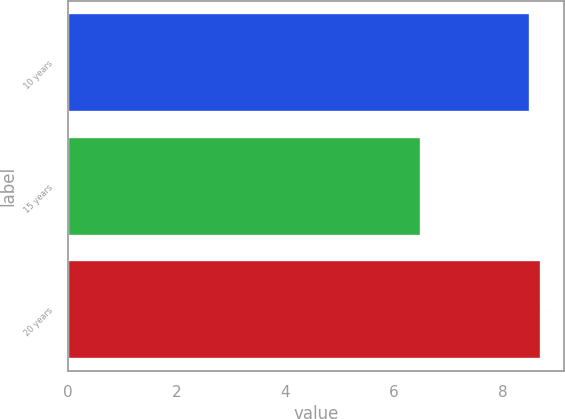<chart> <loc_0><loc_0><loc_500><loc_500><bar_chart><fcel>10 years<fcel>15 years<fcel>20 years<nl><fcel>8.5<fcel>6.5<fcel>8.7<nl></chart> 